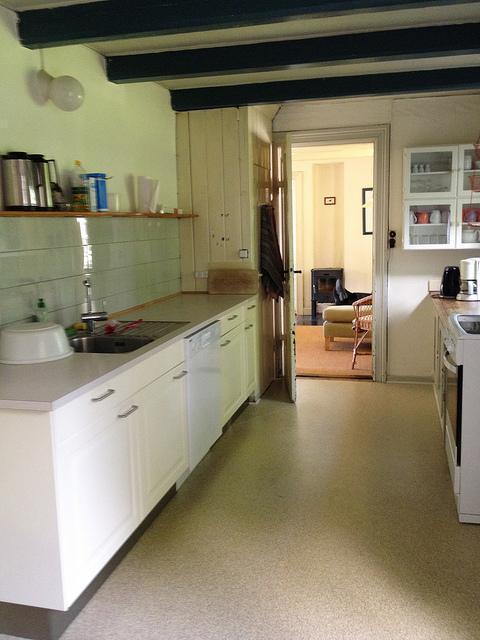What is the most likely activity the person on the yellow chair is doing?
Answer the question by selecting the correct answer among the 4 following choices.
Options: Video game, watching tv, singing, cooking. Watching tv. 